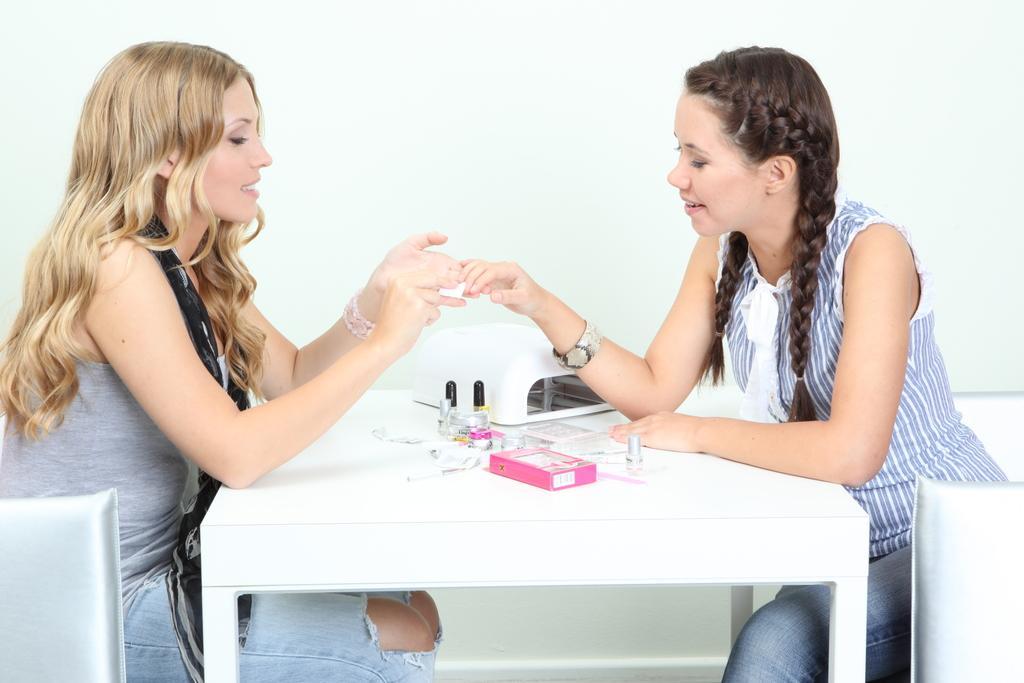How would you summarize this image in a sentence or two? here we can see a woman is sitting on a chair, and in front there is the table and some objects on it, and to opposite her a girl is sitting and smiling, and here is the wall. 